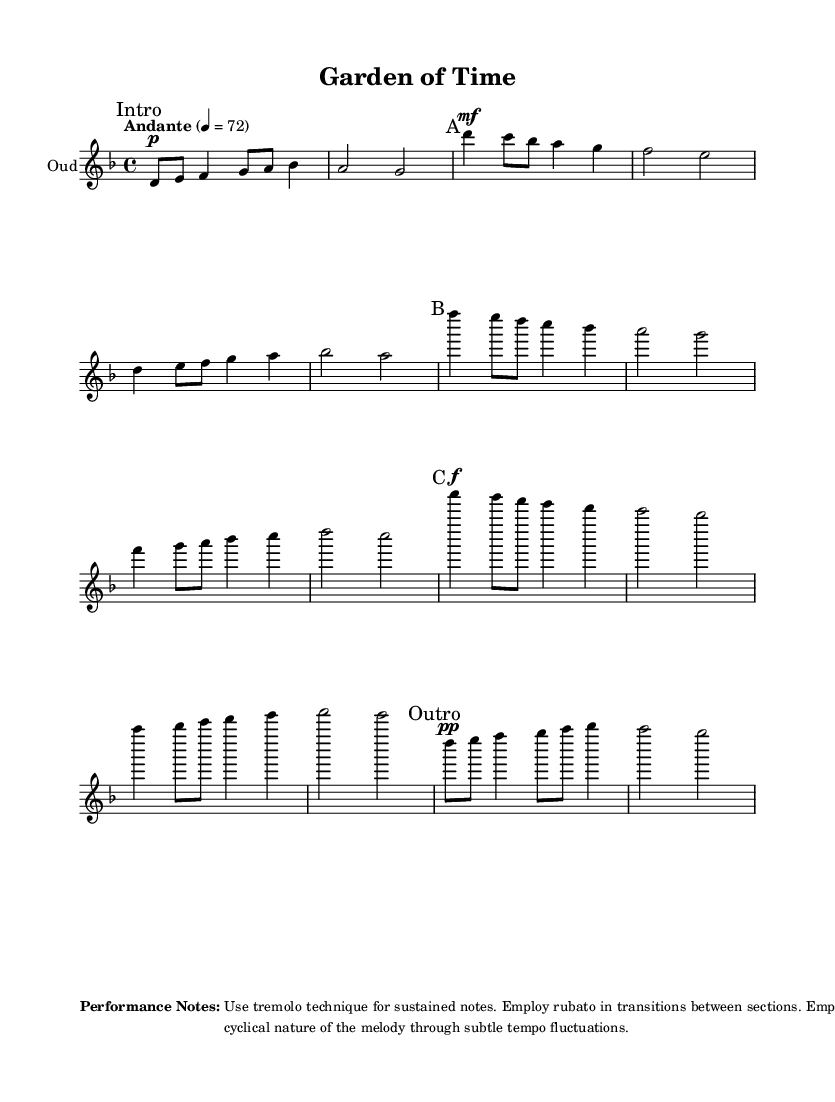What is the key signature of this music? The key signature is D minor, which typically features one flat (B flat). It's indicated at the beginning of the piece where the clef and key signature are shown.
Answer: D minor What is the time signature of this music? The time signature, shown at the beginning of the score, is 4/4, indicating that there are four beats per measure, and each quarter note gets one beat.
Answer: 4/4 What is the tempo marking for this composition? The tempo marking is specified as "Andante" with a metronome marking of quarter note equals 72. This means it should be played at a moderate walking pace.
Answer: Andante How many sections are there in this piece? The piece contains four distinct sections: Intro, A, B, C, and an Outro, as denoted by the section markings throughout the score.
Answer: Five In which section does the highest note occur? The notes progress throughout the sections, and the highest pitch is found in Section C, where there are prominent high notes like A'' and B flat.
Answer: Section C What performance technique is suggested for sustained notes? The performance notes at the end indicate the use of tremolo technique for sustained notes. This technique consists of rapid alternation between two notes, contributing to a rich sound.
Answer: Tremolo What is the purpose of the rubato indicated in the performance notes? The performance notes suggest employing rubato in transitions between sections, which serves to allow expressive flexibility in tempo, helping to emphasize emotional content in the music.
Answer: Expressive flexibility 